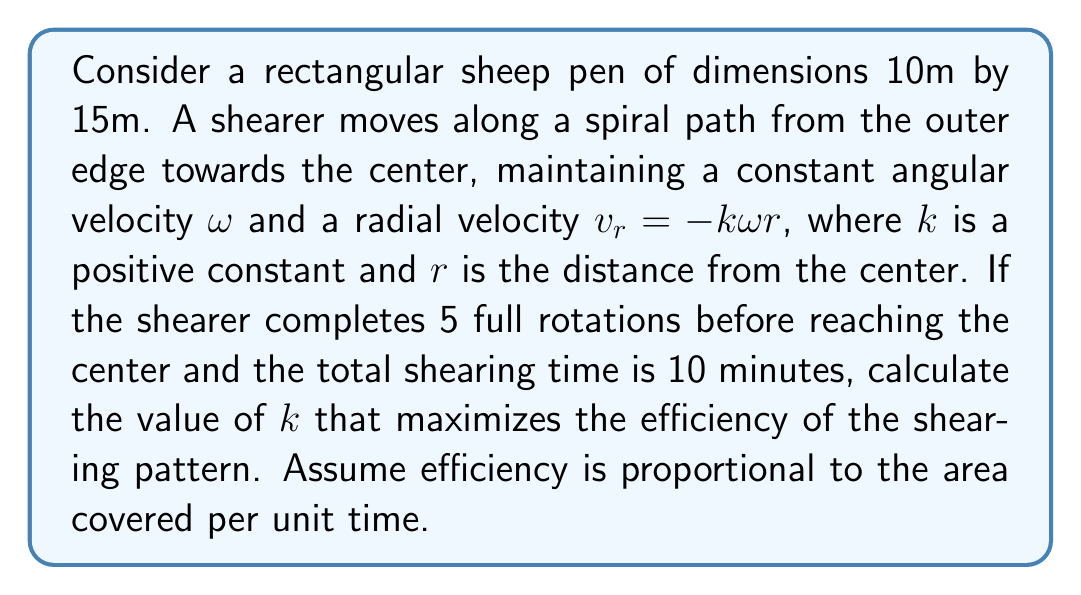Help me with this question. Let's approach this step-by-step using vector calculus:

1) The position vector in polar coordinates is:
   $$\vec{r}(t) = r(t)(\cos(\omega t)\hat{i} + \sin(\omega t)\hat{j})$$

2) We know that $\frac{dr}{dt} = v_r = -k\omega r$. Solving this differential equation:
   $$r(t) = r_0e^{-k\omega t}$$
   where $r_0$ is the initial radius (half the diagonal of the rectangle).

3) The spiral equation in parametric form is:
   $$x = r_0e^{-k\omega t}\cos(\omega t)$$
   $$y = r_0e^{-k\omega t}\sin(\omega t)$$

4) The area covered by the spiral can be calculated using the formula:
   $$A = \frac{1}{2}\int_0^T |\vec{r} \times \vec{v}| dt$$
   where $T$ is the total time and $\vec{v}$ is the velocity vector.

5) The velocity vector is:
   $$\vec{v} = \frac{d\vec{r}}{dt} = r_0e^{-k\omega t}(-k\omega\cos(\omega t) - \sin(\omega t))\hat{i} + r_0e^{-k\omega t}(-k\omega\sin(\omega t) + \cos(\omega t))\hat{j}$$

6) Calculating the cross product:
   $$|\vec{r} \times \vec{v}| = r_0^2e^{-2k\omega t}(1+k)\omega$$

7) Integrating to find the area:
   $$A = \frac{1}{2}r_0^2(1+k)\omega\int_0^T e^{-2k\omega t} dt = \frac{r_0^2(1+k)}{4k}(1-e^{-2k\omega T})$$

8) We know that 5 full rotations are completed in 10 minutes, so:
   $$\omega T = 10\pi$$
   $$T = 10 \text{ minutes}$$

9) The initial radius $r_0$ is half the diagonal of the rectangle:
   $$r_0 = \frac{1}{2}\sqrt{10^2 + 15^2} = \frac{25}{2}\text{ m}$$

10) To maximize efficiency, we need to maximize $\frac{A}{T}$. This is equivalent to maximizing:
    $$f(k) = \frac{(1+k)}{4k}(1-e^{-20\pi k})$$

11) To find the maximum, we differentiate $f(k)$ and set it to zero:
    $$f'(k) = \frac{1-e^{-20\pi k}}{4k^2} - \frac{1+k}{4k}(20\pi e^{-20\pi k}) + \frac{1-e^{-20\pi k}}{4k} = 0$$

12) This equation can be solved numerically to find the optimal value of $k$.
Answer: $k \approx 0.0798$ 